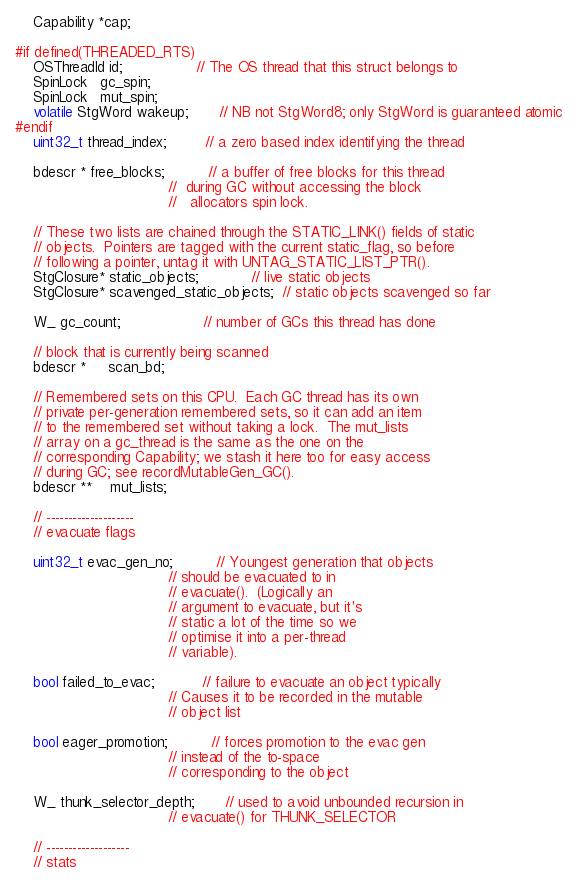Convert code to text. <code><loc_0><loc_0><loc_500><loc_500><_C_>    Capability *cap;

#if defined(THREADED_RTS)
    OSThreadId id;                 // The OS thread that this struct belongs to
    SpinLock   gc_spin;
    SpinLock   mut_spin;
    volatile StgWord wakeup;       // NB not StgWord8; only StgWord is guaranteed atomic
#endif
    uint32_t thread_index;         // a zero based index identifying the thread

    bdescr * free_blocks;          // a buffer of free blocks for this thread
                                   //  during GC without accessing the block
                                   //   allocators spin lock.

    // These two lists are chained through the STATIC_LINK() fields of static
    // objects.  Pointers are tagged with the current static_flag, so before
    // following a pointer, untag it with UNTAG_STATIC_LIST_PTR().
    StgClosure* static_objects;            // live static objects
    StgClosure* scavenged_static_objects;  // static objects scavenged so far

    W_ gc_count;                   // number of GCs this thread has done

    // block that is currently being scanned
    bdescr *     scan_bd;

    // Remembered sets on this CPU.  Each GC thread has its own
    // private per-generation remembered sets, so it can add an item
    // to the remembered set without taking a lock.  The mut_lists
    // array on a gc_thread is the same as the one on the
    // corresponding Capability; we stash it here too for easy access
    // during GC; see recordMutableGen_GC().
    bdescr **    mut_lists;

    // --------------------
    // evacuate flags

    uint32_t evac_gen_no;          // Youngest generation that objects
                                   // should be evacuated to in
                                   // evacuate().  (Logically an
                                   // argument to evacuate, but it's
                                   // static a lot of the time so we
                                   // optimise it into a per-thread
                                   // variable).

    bool failed_to_evac;           // failure to evacuate an object typically
                                   // Causes it to be recorded in the mutable
                                   // object list

    bool eager_promotion;          // forces promotion to the evac gen
                                   // instead of the to-space
                                   // corresponding to the object

    W_ thunk_selector_depth;       // used to avoid unbounded recursion in
                                   // evacuate() for THUNK_SELECTOR

    // -------------------
    // stats
</code> 